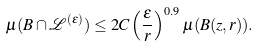Convert formula to latex. <formula><loc_0><loc_0><loc_500><loc_500>\mu ( B \cap \mathcal { L } ^ { ( \epsilon ) } ) \leq 2 C \left ( \frac { \epsilon } { r } \right ) ^ { 0 . 9 } \mu ( B ( z , r ) ) .</formula> 